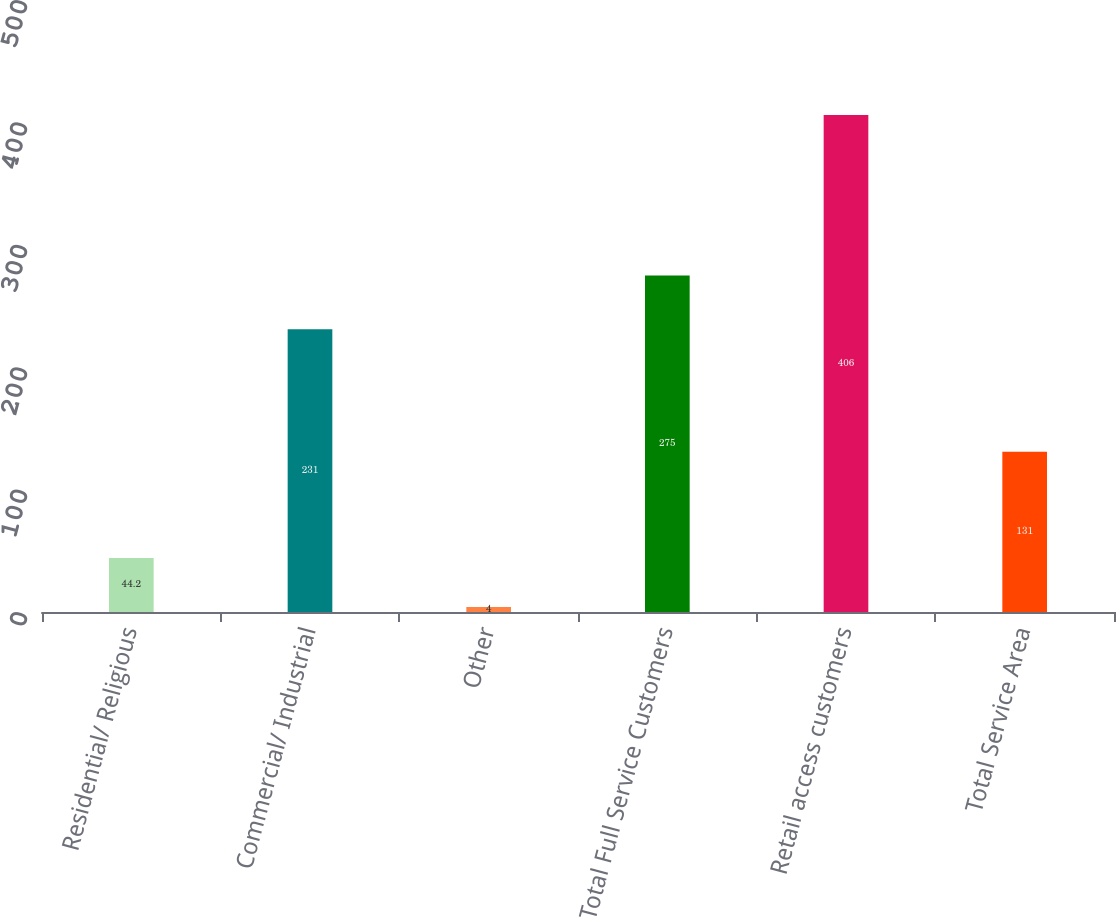Convert chart to OTSL. <chart><loc_0><loc_0><loc_500><loc_500><bar_chart><fcel>Residential/ Religious<fcel>Commercial/ Industrial<fcel>Other<fcel>Total Full Service Customers<fcel>Retail access customers<fcel>Total Service Area<nl><fcel>44.2<fcel>231<fcel>4<fcel>275<fcel>406<fcel>131<nl></chart> 